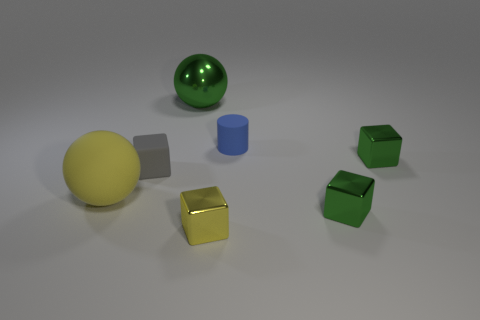Do the small green thing that is behind the yellow matte sphere and the tiny matte object that is to the left of the small yellow shiny object have the same shape?
Keep it short and to the point. Yes. How many other things are the same material as the cylinder?
Offer a terse response. 2. There is a yellow object that is made of the same material as the big green thing; what shape is it?
Your answer should be compact. Cube. Does the blue cylinder have the same size as the yellow shiny block?
Your response must be concise. Yes. There is a green cube that is in front of the large ball that is on the left side of the green metallic ball; how big is it?
Provide a short and direct response. Small. What shape is the metal thing that is the same color as the rubber sphere?
Your answer should be compact. Cube. What number of cylinders are small shiny things or brown objects?
Provide a short and direct response. 0. Do the gray cube and the object that is to the left of the tiny gray object have the same size?
Make the answer very short. No. Are there more blue objects that are left of the metal ball than gray cylinders?
Ensure brevity in your answer.  No. What size is the blue cylinder that is the same material as the large yellow object?
Give a very brief answer. Small. 